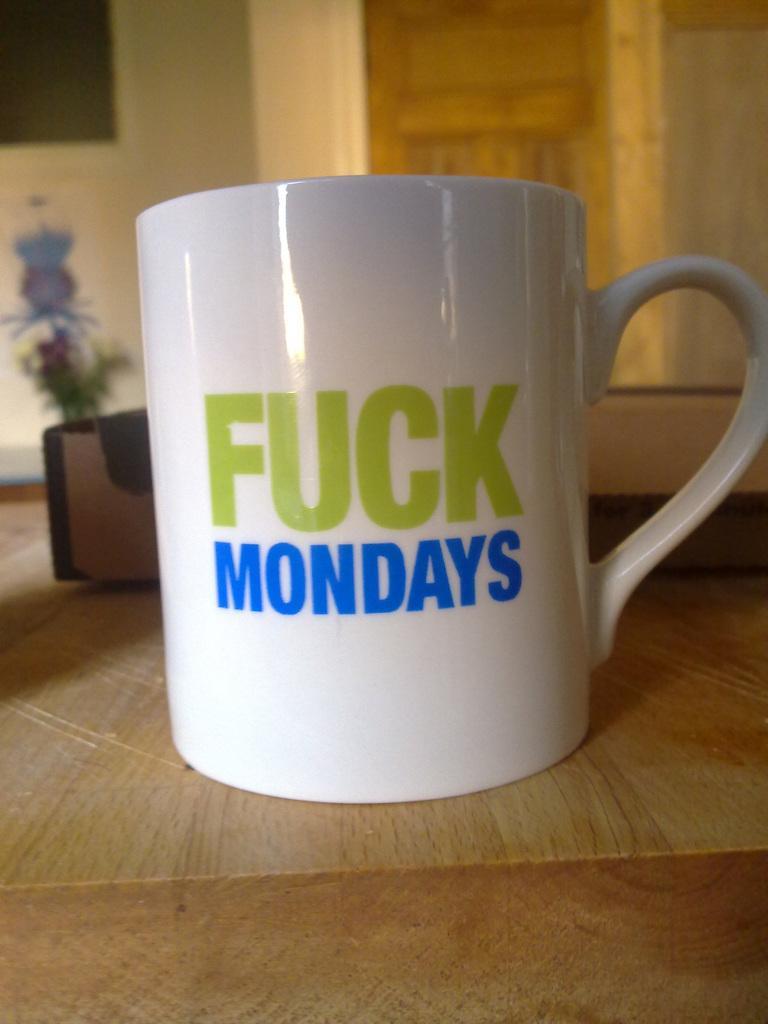Please provide a concise description of this image. In this picture, we can see the ground, and we can see cup, and some objects on the ground, we can see the wall with some objects attached to it. 